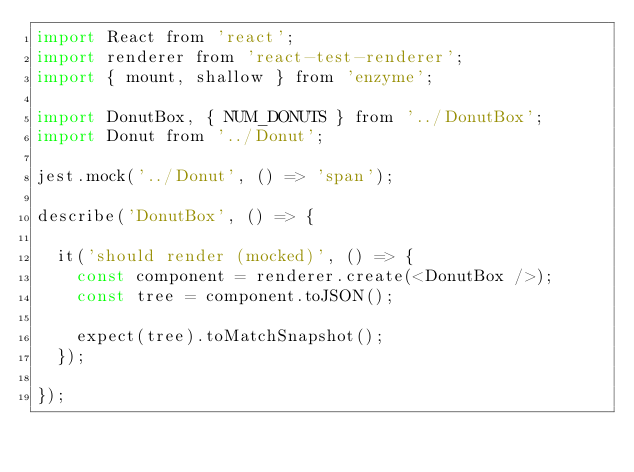<code> <loc_0><loc_0><loc_500><loc_500><_JavaScript_>import React from 'react';
import renderer from 'react-test-renderer';
import { mount, shallow } from 'enzyme';

import DonutBox, { NUM_DONUTS } from '../DonutBox';
import Donut from '../Donut';

jest.mock('../Donut', () => 'span');

describe('DonutBox', () => {

  it('should render (mocked)', () => {
    const component = renderer.create(<DonutBox />);
    const tree = component.toJSON();

    expect(tree).toMatchSnapshot();
  });

});
</code> 